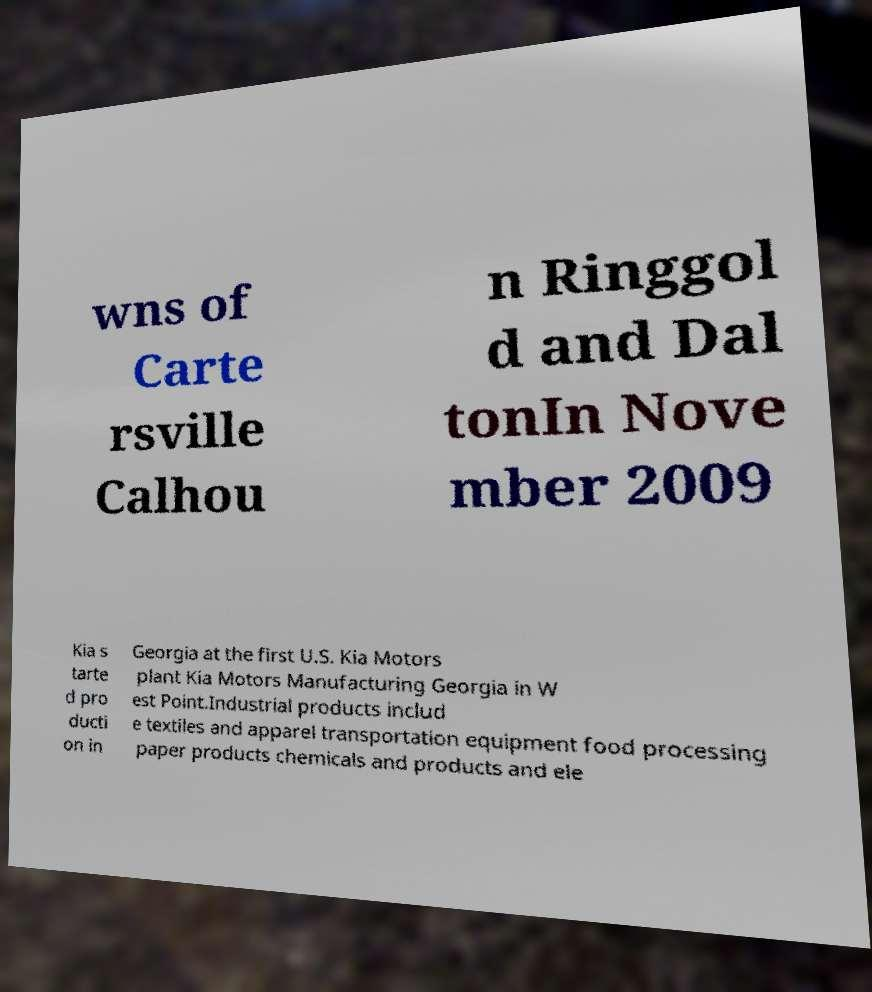I need the written content from this picture converted into text. Can you do that? wns of Carte rsville Calhou n Ringgol d and Dal tonIn Nove mber 2009 Kia s tarte d pro ducti on in Georgia at the first U.S. Kia Motors plant Kia Motors Manufacturing Georgia in W est Point.Industrial products includ e textiles and apparel transportation equipment food processing paper products chemicals and products and ele 